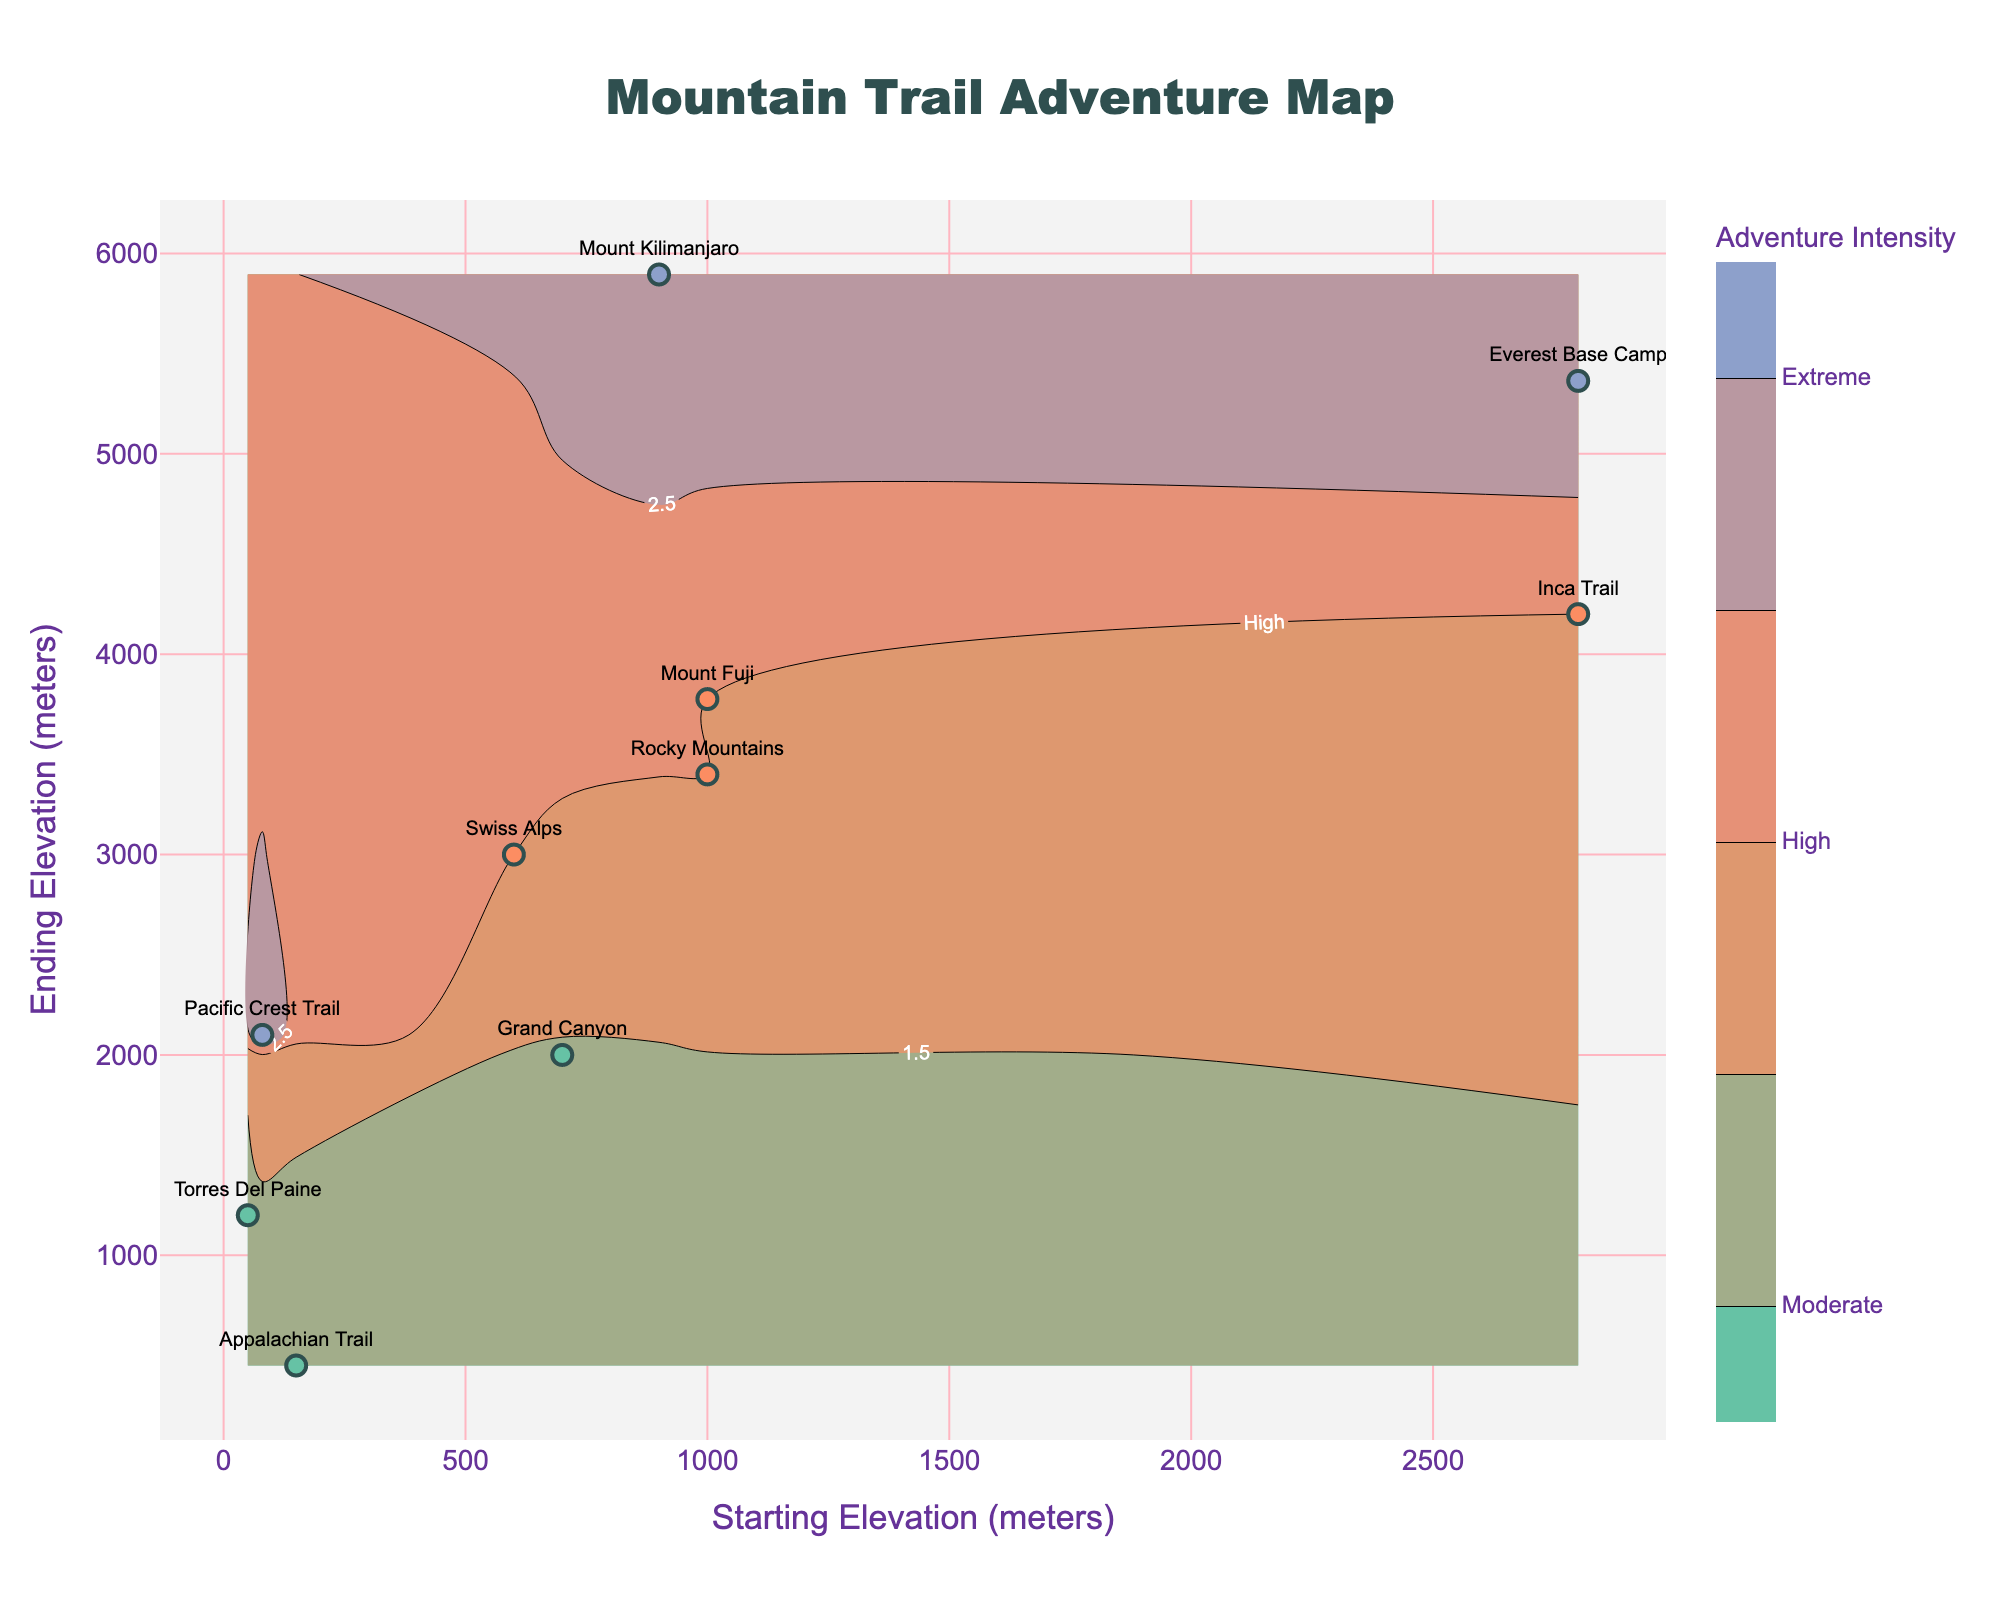What is the title of the figure? The title of the figure is prominently displayed at the top center of the plot, making it easy to locate and read.
Answer: Mountain Trail Adventure Map What is the color used for trails with a "High" adventure intensity level? The figure uses a distinct color for each adventure intensity level. By referring to the legend or color bar, it is clear that the color for "High" adventure intensity is an orange shade.
Answer: Orange What do the x-axis and y-axis represent? The x-axis and y-axis are labeled to indicate what they represent. By looking at the axis titles, it is clear that the x-axis represents "Starting Elevation (meters)" and the y-axis represents "Ending Elevation (meters)".
Answer: Starting Elevation (meters) and Ending Elevation (meters) How many trails have an "Extreme" adventure intensity level? By analyzing the contour plot and the color bar, we can count the number of data points that fall within the "Extreme" intensity level, which is represented by a specific color. There are three trails marked with the "Extreme" level: Pacific Crest Trail, Mount Kilimanjaro, and Everest Base Camp.
Answer: Three Which trail starts at the highest elevation? The starting elevations are plotted along the x-axis. By locating the data point furthest to the right, the highest starting elevation can be identified. The Inca Trail starts at 2800 meters, which is the highest starting elevation.
Answer: Inca Trail Which trail has the biggest elevation gain? The elevation gain is the difference between the ending elevation and starting elevation. By comparing these differences for each trail, the trail with the largest elevation gain can be identified. Mount Kilimanjaro has the biggest elevation gain, starting at 900 meters and ending at 5895 meters, yielding a gain of 4995 meters.
Answer: Mount Kilimanjaro Compare the adventure intensity levels of Appalachian Trail and Mount Fuji. Which one is higher? By checking the colors associated with the Appalachian Trail and Mount Fuji data points, their respective adventure intensity levels can be compared. The Appalachian Trail is marked as "Moderate" while Mount Fuji is marked as "High," indicating a higher intensity for Mount Fuji.
Answer: Mount Fuji What is the median ending elevation among all the trails? To find the median ending elevation, first list all the ending elevations: 450, 2100, 5895, 4200, 5364, 3000, 3400, 2000, 3776, 1200. Then, sort these values: 450, 1200, 2000, 2100, 3000, 3400, 3776, 4200, 5364, 5895. The median is the average of the 5th and 6th values, (3000 + 3400) / 2 = 3200 meters.
Answer: 3200 meters 